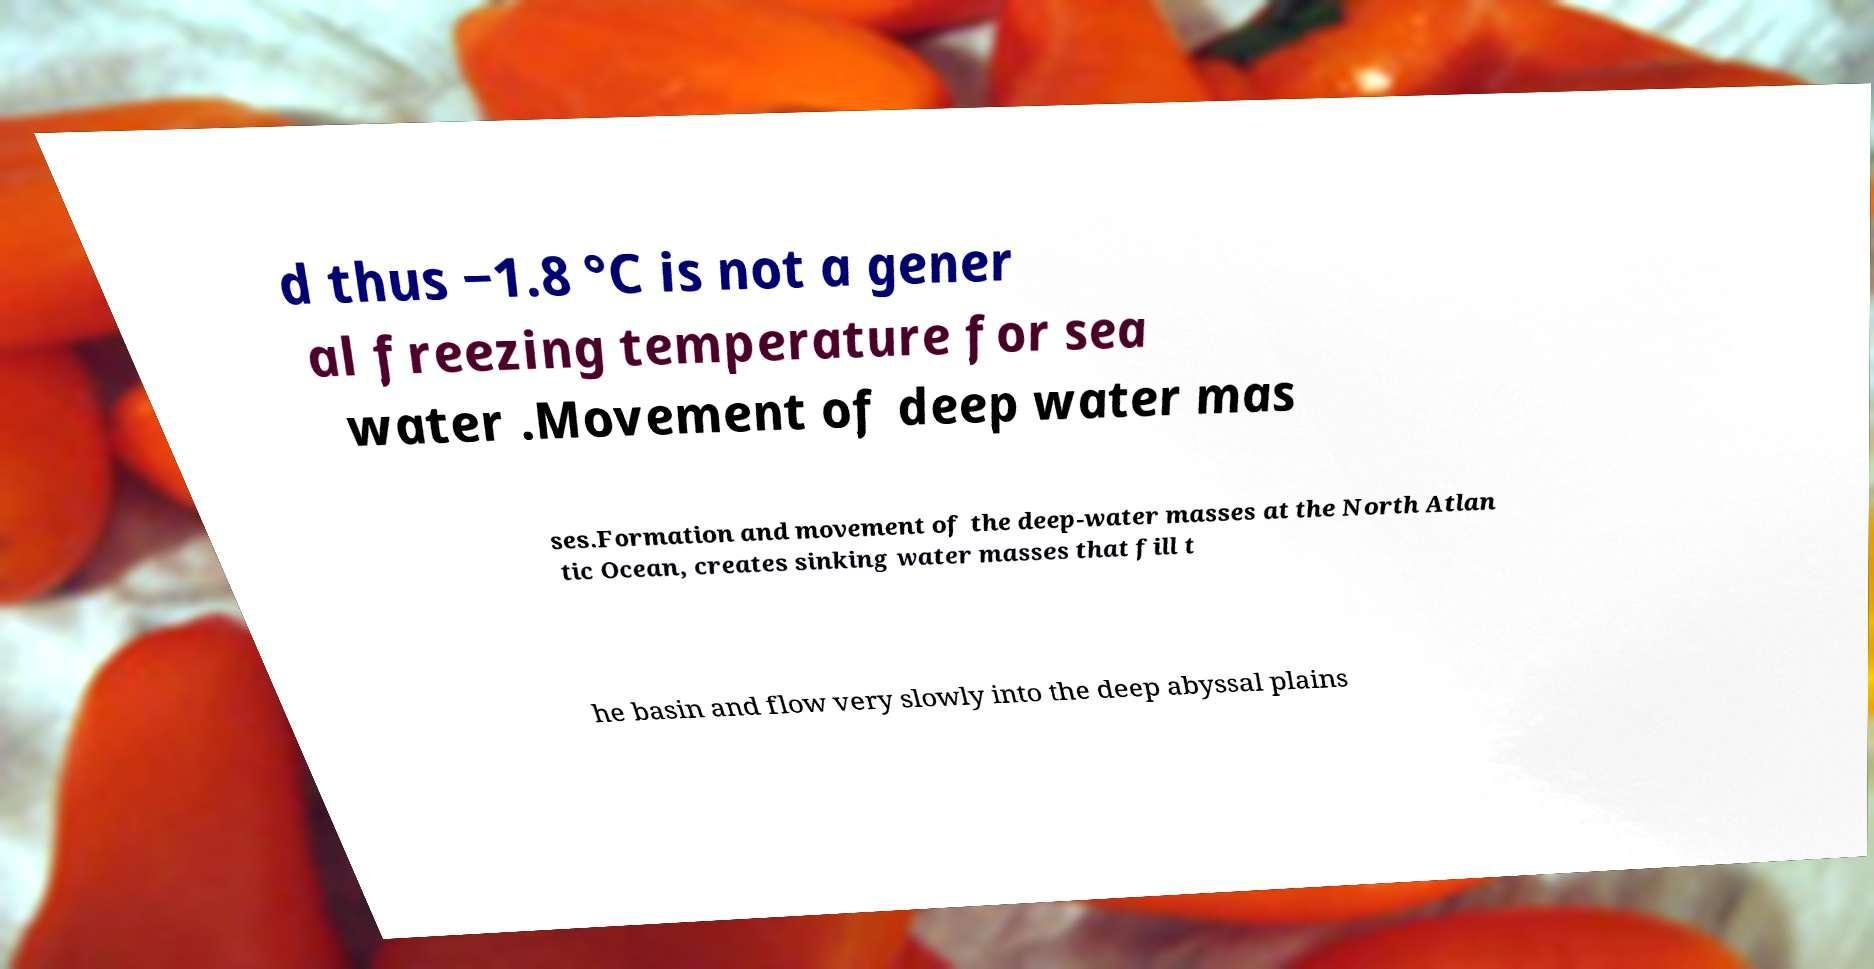Can you accurately transcribe the text from the provided image for me? d thus −1.8 °C is not a gener al freezing temperature for sea water .Movement of deep water mas ses.Formation and movement of the deep-water masses at the North Atlan tic Ocean, creates sinking water masses that fill t he basin and flow very slowly into the deep abyssal plains 